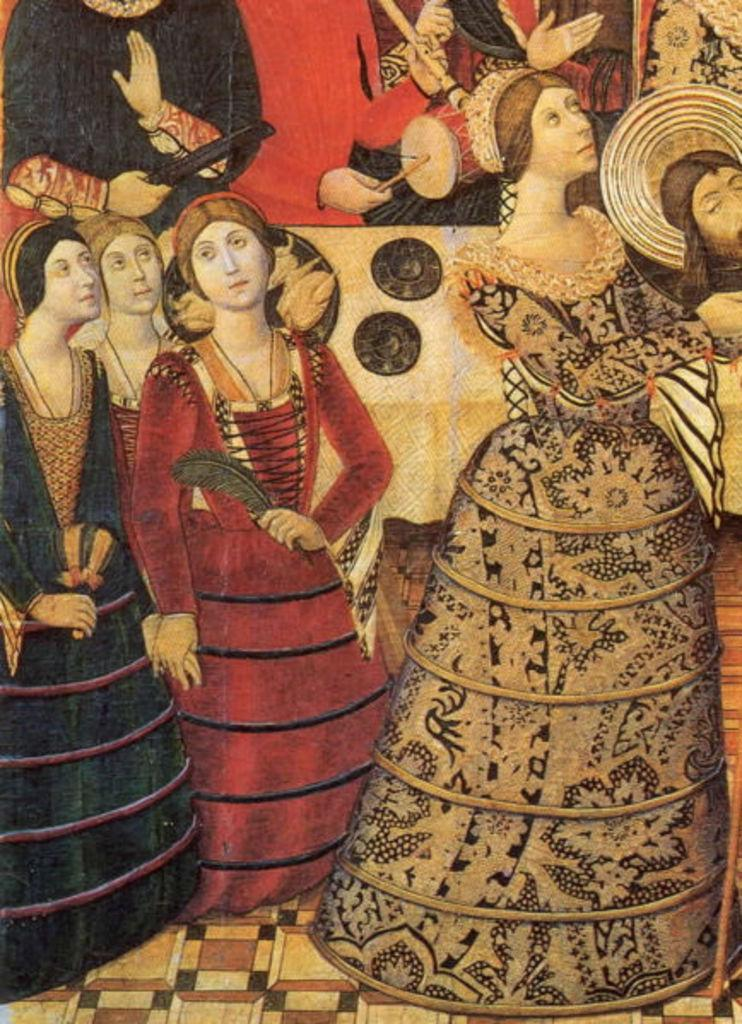What is the main subject of the image? There is a painting in the image. What is depicted in the painting? The painting contains a group of persons. Can you describe the actions of any of the persons in the painting? One person in the painting is playing a musical instrument. What type of snake can be seen slithering through the painting? There is no snake present in the painting; it features a group of persons and one person playing a musical instrument. 